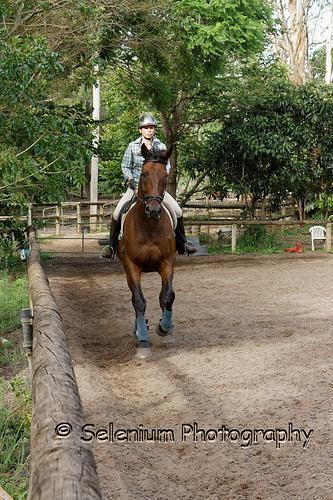How many horses are shown?
Give a very brief answer. 1. 